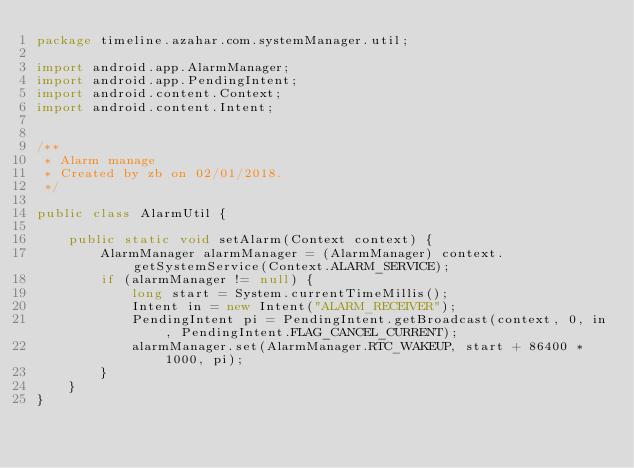<code> <loc_0><loc_0><loc_500><loc_500><_Java_>package timeline.azahar.com.systemManager.util;

import android.app.AlarmManager;
import android.app.PendingIntent;
import android.content.Context;
import android.content.Intent;


/**
 * Alarm manage
 * Created by zb on 02/01/2018.
 */

public class AlarmUtil {

    public static void setAlarm(Context context) {
        AlarmManager alarmManager = (AlarmManager) context.getSystemService(Context.ALARM_SERVICE);
        if (alarmManager != null) {
            long start = System.currentTimeMillis();
            Intent in = new Intent("ALARM_RECEIVER");
            PendingIntent pi = PendingIntent.getBroadcast(context, 0, in, PendingIntent.FLAG_CANCEL_CURRENT);
            alarmManager.set(AlarmManager.RTC_WAKEUP, start + 86400 * 1000, pi);
        }
    }
}
</code> 